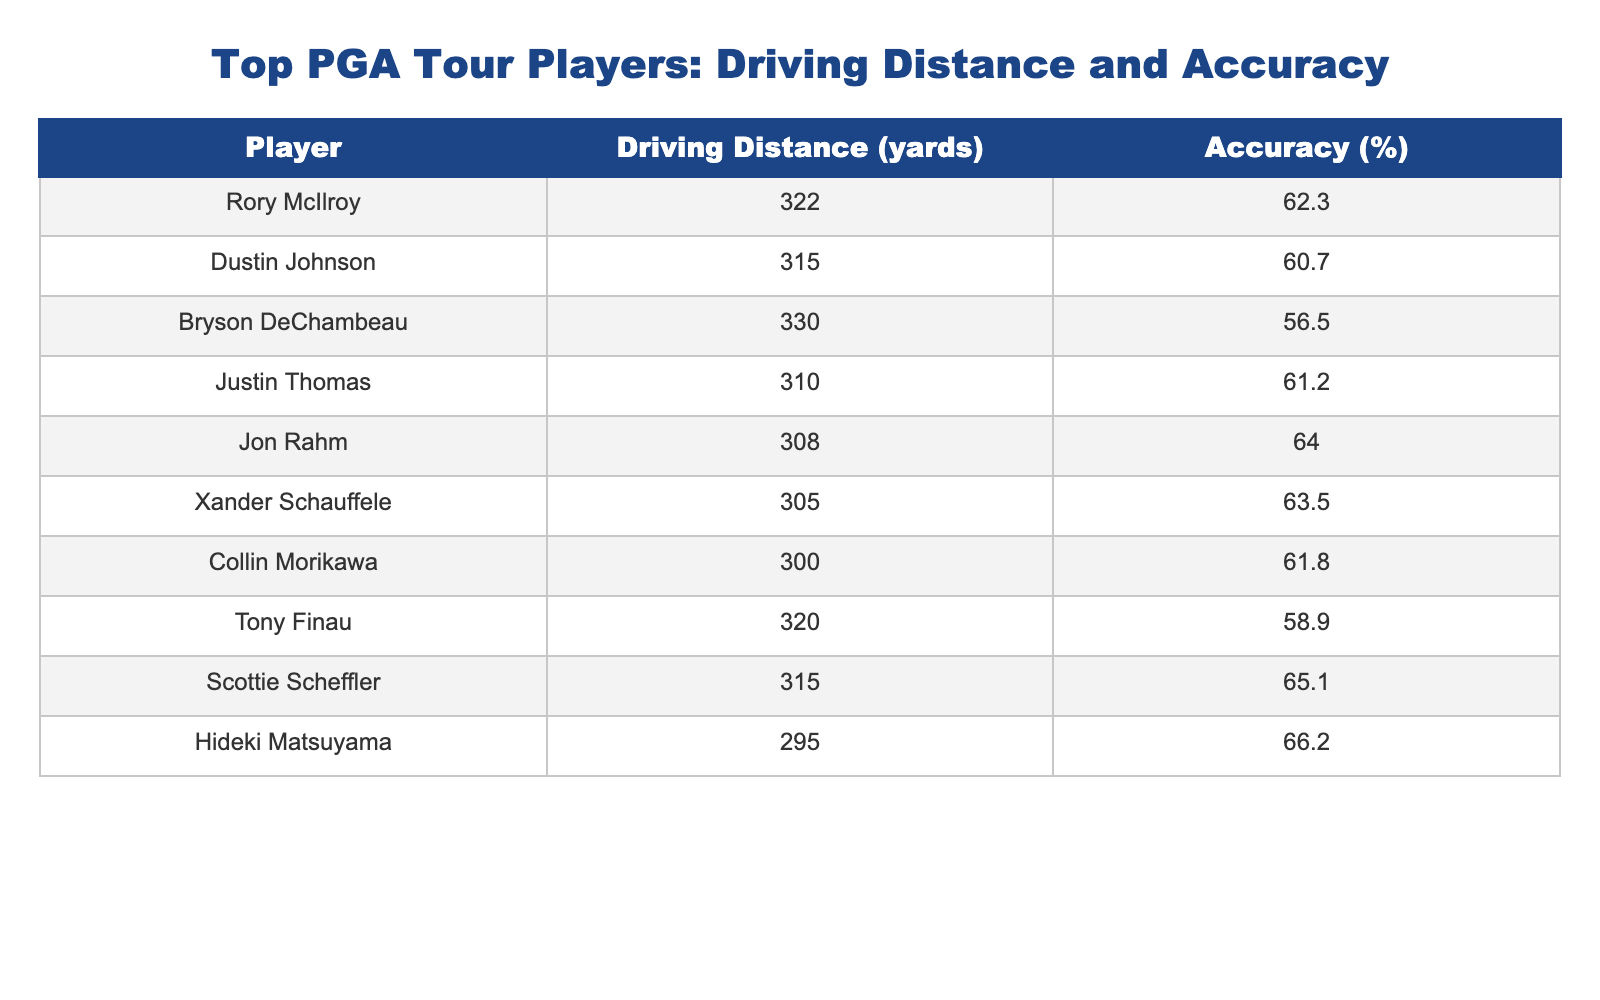What is the driving distance of Bryson DeChambeau? Bryson DeChambeau’s driving distance is directly listed in the table, which states he hits an average of 330 yards.
Answer: 330 yards Who is the most accurate player on this list? The accuracy of each player is shown in the table, and Hideki Matsuyama has the highest accuracy percentage at 66.2%.
Answer: Hideki Matsuyama What is the average driving distance of all players listed? To calculate the average driving distance, sum all the driving distances: (322 + 315 + 330 + 310 + 308 + 305 + 300 + 320 + 315 + 295) = 3,215 yards. There are 10 players, so the average is 3,215 / 10 = 321.5 yards.
Answer: 321.5 yards Is Collin Morikawa less accurate than Tony Finau? The accuracy for Collin Morikawa is 61.8%, while for Tony Finau it is 58.9%. Since 61.8% is greater than 58.9%, it is false that Morikawa is less accurate than Finau.
Answer: No What is the difference in driving distance between Rory McIlroy and Jon Rahm? Rory McIlroy’s driving distance is 322 yards, and Jon Rahm’s is 308 yards. The difference is calculated by subtracting Jon Rahm’s distance from Rory McIlroy’s: 322 - 308 = 14 yards.
Answer: 14 yards Is anyone hitting drives over 325 yards? Looking at the driving distances from the table, Rory McIlroy at 322 yards and Bryson DeChambeau at 330 yards have the respective distances, indicating that DeChambeau is indeed over 325 yards. Thus, yes, at least one player exceeds that distance.
Answer: Yes Which player drives the shortest distance, and what is that distance? The shortest distance can be found by comparing all driving distances in the table. The data shows that Hideki Matsuyama has the lowest driving distance at 295 yards.
Answer: 295 yards What is the combined accuracy percentage of the three players with the highest accuracy? The top three players with the highest accuracy are Hideki Matsuyama (66.2%), Scottie Scheffler (65.1%), and Jon Rahm (64.0%). Adding these values gives 66.2 + 65.1 + 64.0 = 195.3%.
Answer: 195.3% 